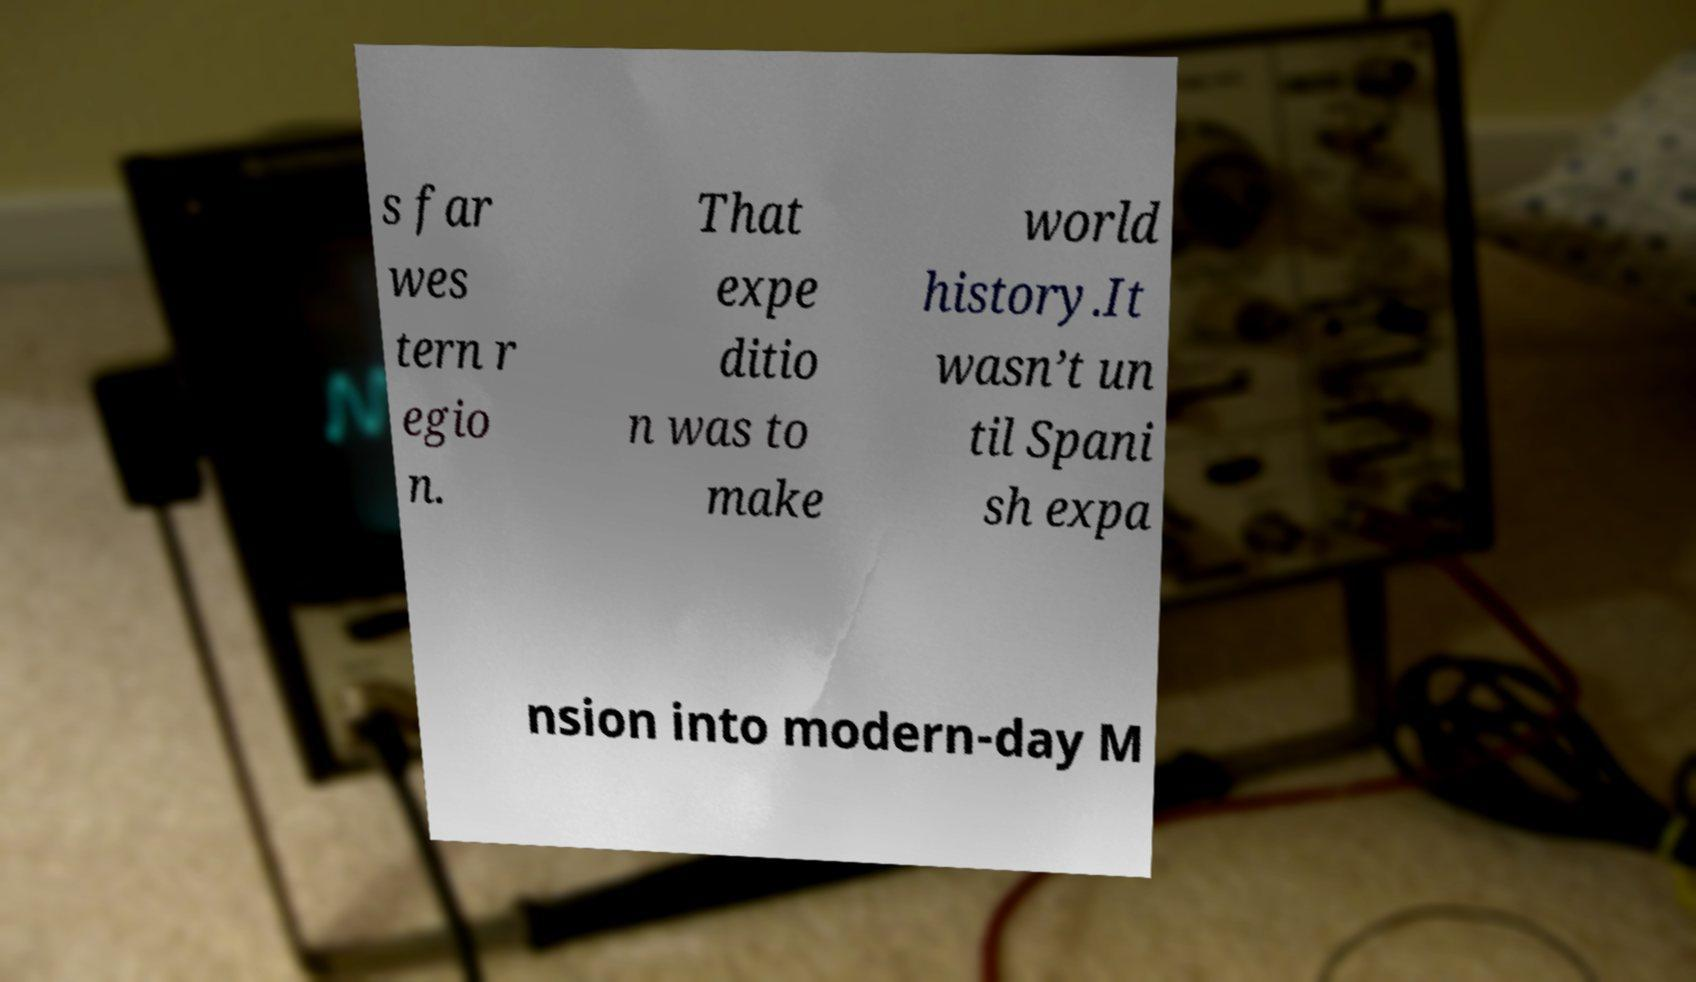I need the written content from this picture converted into text. Can you do that? s far wes tern r egio n. That expe ditio n was to make world history.It wasn’t un til Spani sh expa nsion into modern-day M 